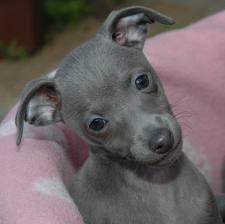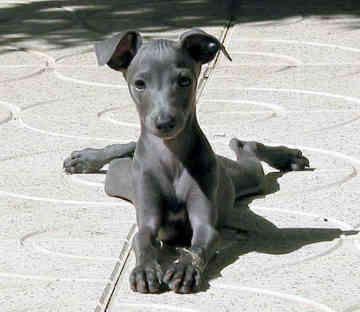The first image is the image on the left, the second image is the image on the right. Given the left and right images, does the statement "One image shows a light brown dog standing." hold true? Answer yes or no. No. 